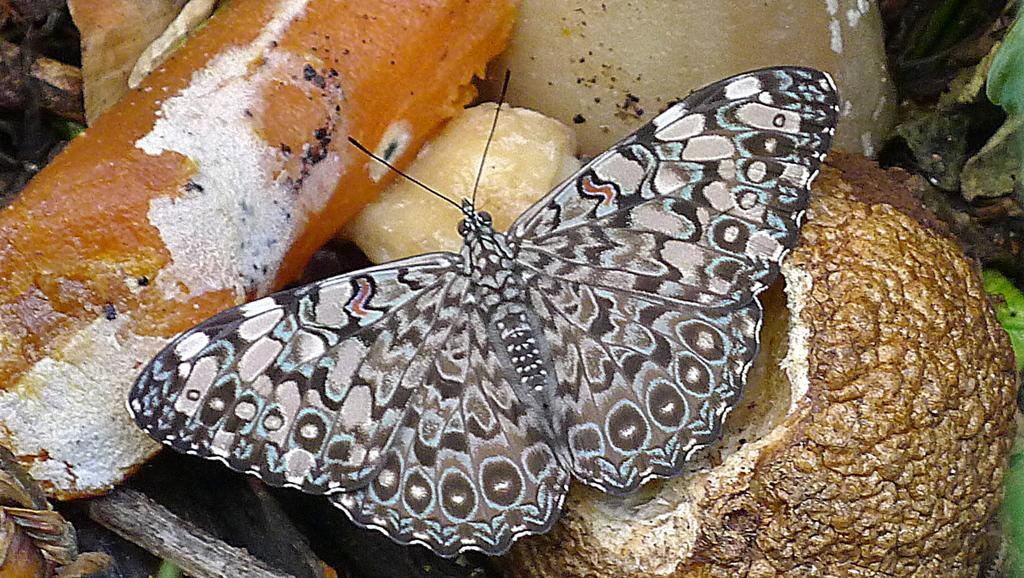What type of animal can be seen in the image? There is a butterfly in the image. What else is present in the image besides the butterfly? There are food items in the image. What type of control can be seen in the image? There is no control present in the image. How many babies are visible in the image? There are no babies present in the image. 